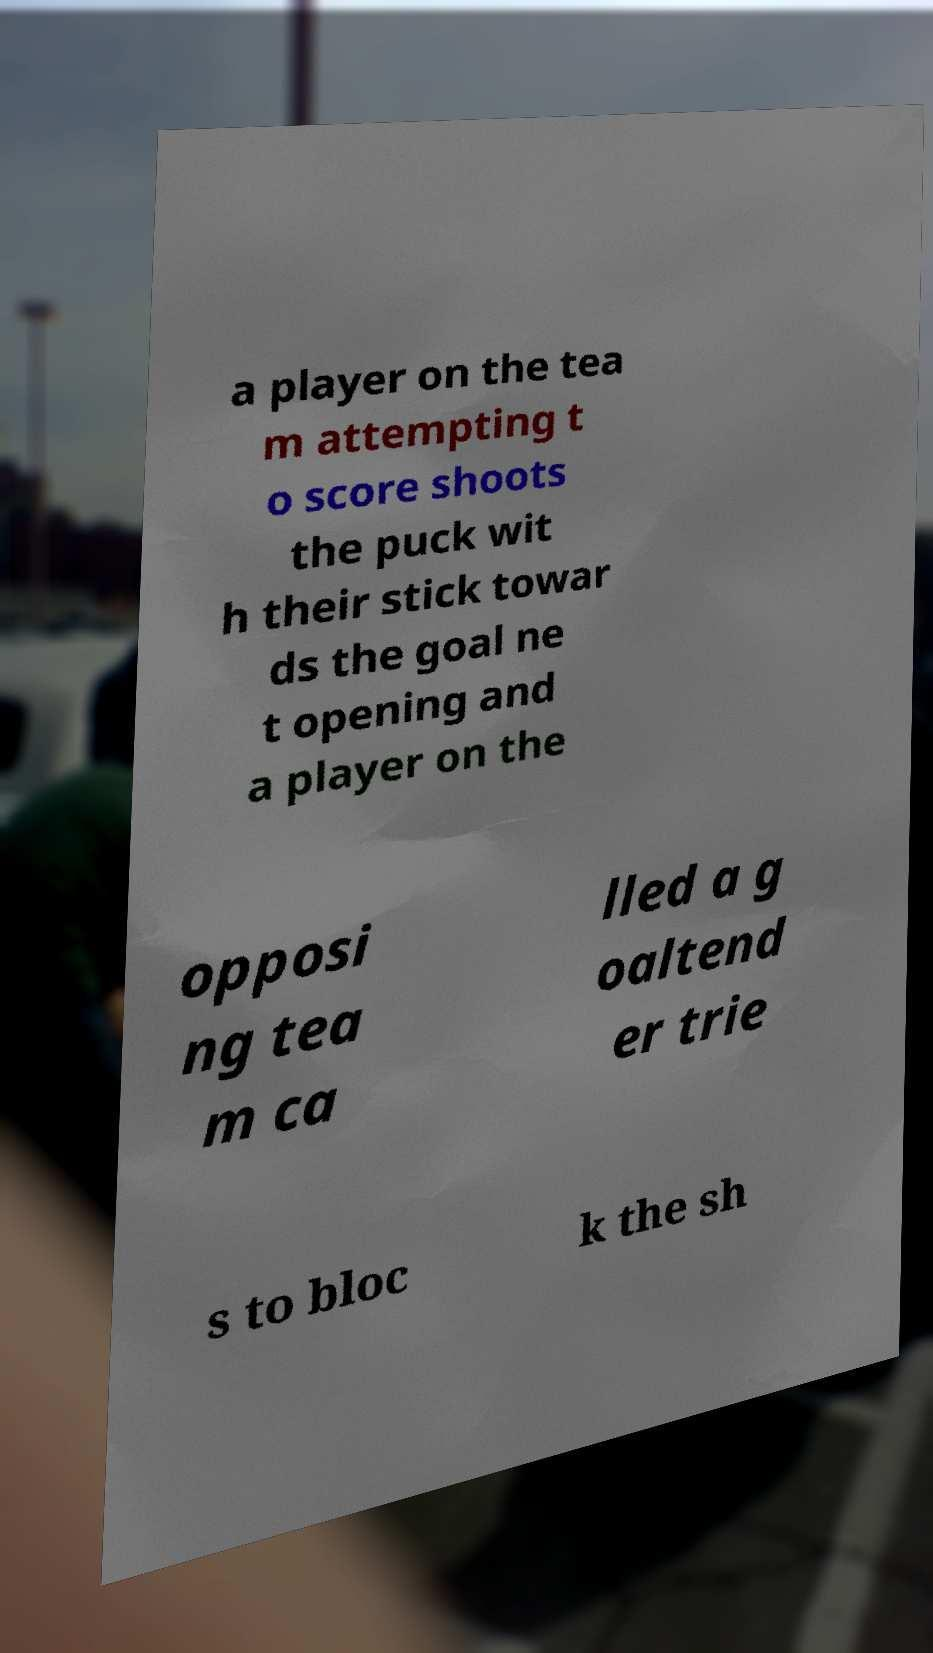Could you assist in decoding the text presented in this image and type it out clearly? a player on the tea m attempting t o score shoots the puck wit h their stick towar ds the goal ne t opening and a player on the opposi ng tea m ca lled a g oaltend er trie s to bloc k the sh 